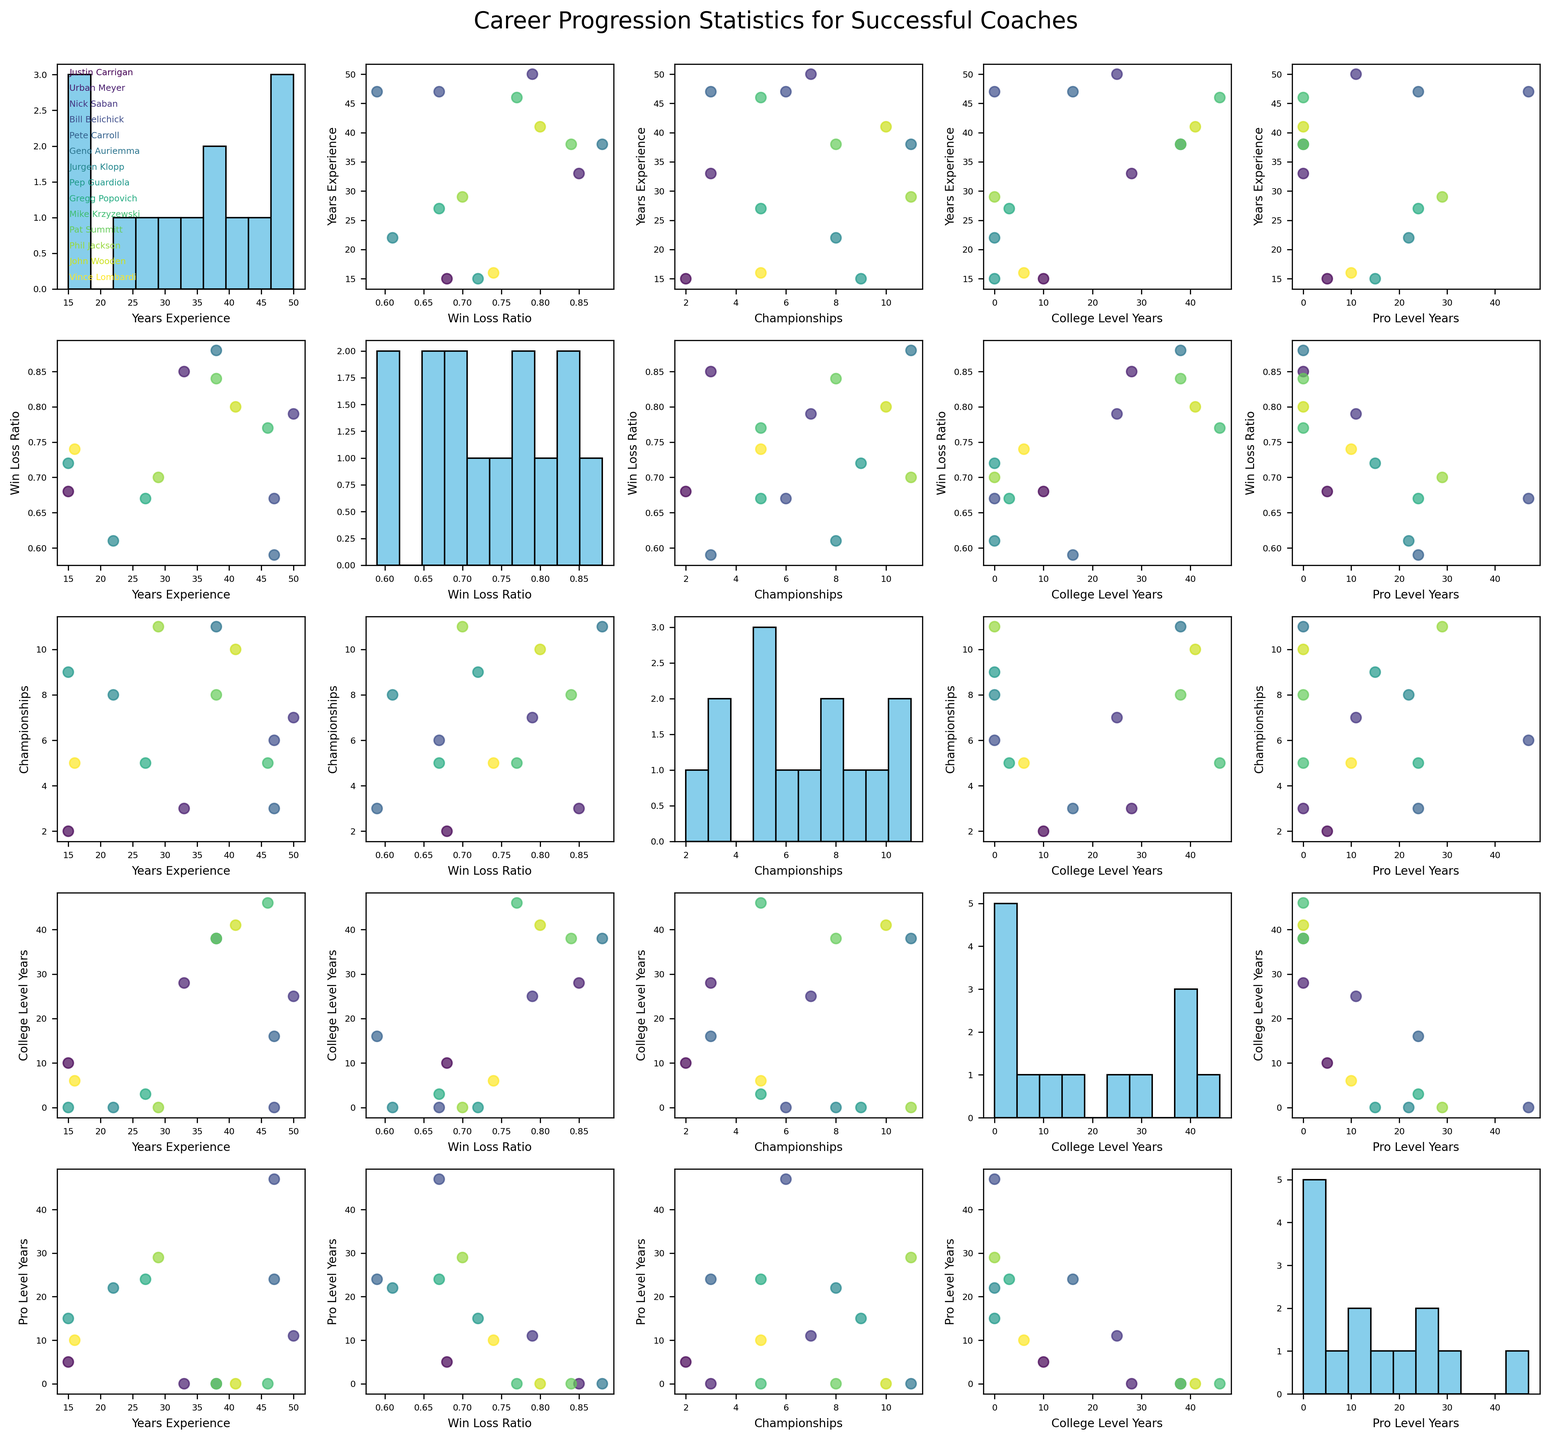How many coaches have more than 30 years of experience? Count the number of coaches in the 'Years_Experience' column that have values greater than 30. There are five coaches: Urban Meyer (33), Nick Saban (50), Bill Belichick (47), Pete Carroll (47), Geno Auriemma (38), and Mike Krzyzewski (46).
Answer: Six Which coach has the highest win-loss ratio? Identify the coach with the maximum value in the 'Win_Loss_Ratio' column. Geno Auriemma has a win-loss ratio of 0.88, the highest among all the coaches.
Answer: Geno Auriemma What is the total number of championships won by Pat Summitt and John Wooden combined? Add the values in the 'Championships' column for Pat Summitt and John Wooden. Pat Summitt won 8 championships, and John Wooden won 10 championships. Their total is 8 + 10 = 18.
Answer: 18 What is the average number of college-level years for coaches with more than 0.70 win-loss ratio? First, filter the coaches with a win-loss ratio above 0.70: Urban Meyer (28), Nick Saban (25), Geno Auriemma (38), Mike Krzyzewski (46), and John Wooden (41). Calculate their average college-level years: (28 + 25 + 38 + 46 + 41) / 5 = 35.6
Answer: 35.6 How many coaches have won more than 5 championships? Count the number of coaches with values greater than 5 in the 'Championships' column. The relevant coaches are Nick Saban (7), Bill Belichick (6), Geno Auriemma (11), Pep Guardiola (9), Phil Jackson (11), John Wooden (10), and Vince Lombardi (5).
Answer: 6 Which two features have the strongest positive correlation? By examining the scatterplot matrix, identify the pairs with the most clearly visible positive correlations. There is a notably strong positive correlation between 'Years_Experience' and 'Pro_Level_Years'.
Answer: Years_Experience and Pro_Level_Years Compare the win-loss ratio of Justin Carrigan and Bill Belichick. Who has the higher ratio? Look at the 'Win_Loss_Ratio' values for both coaches. Justin Carrigan has a win-loss ratio of 0.68, while Bill Belichick has a win-loss ratio of 0.67. Justin Carrigan has a slightly higher win-loss ratio.
Answer: Justin Carrigan In what feature does Pep Guardiola outperform Jurgen Klopp? Compare the respective features for Pep Guardiola and Jurgen Klopp. Pep Guardiola outperforms Jurgen Klopp in the 'Win_Loss_Ratio' (0.72 vs. 0.61) and 'Championships' (9 vs. 8) categories.
Answer: Win_Loss_Ratio and Championships 